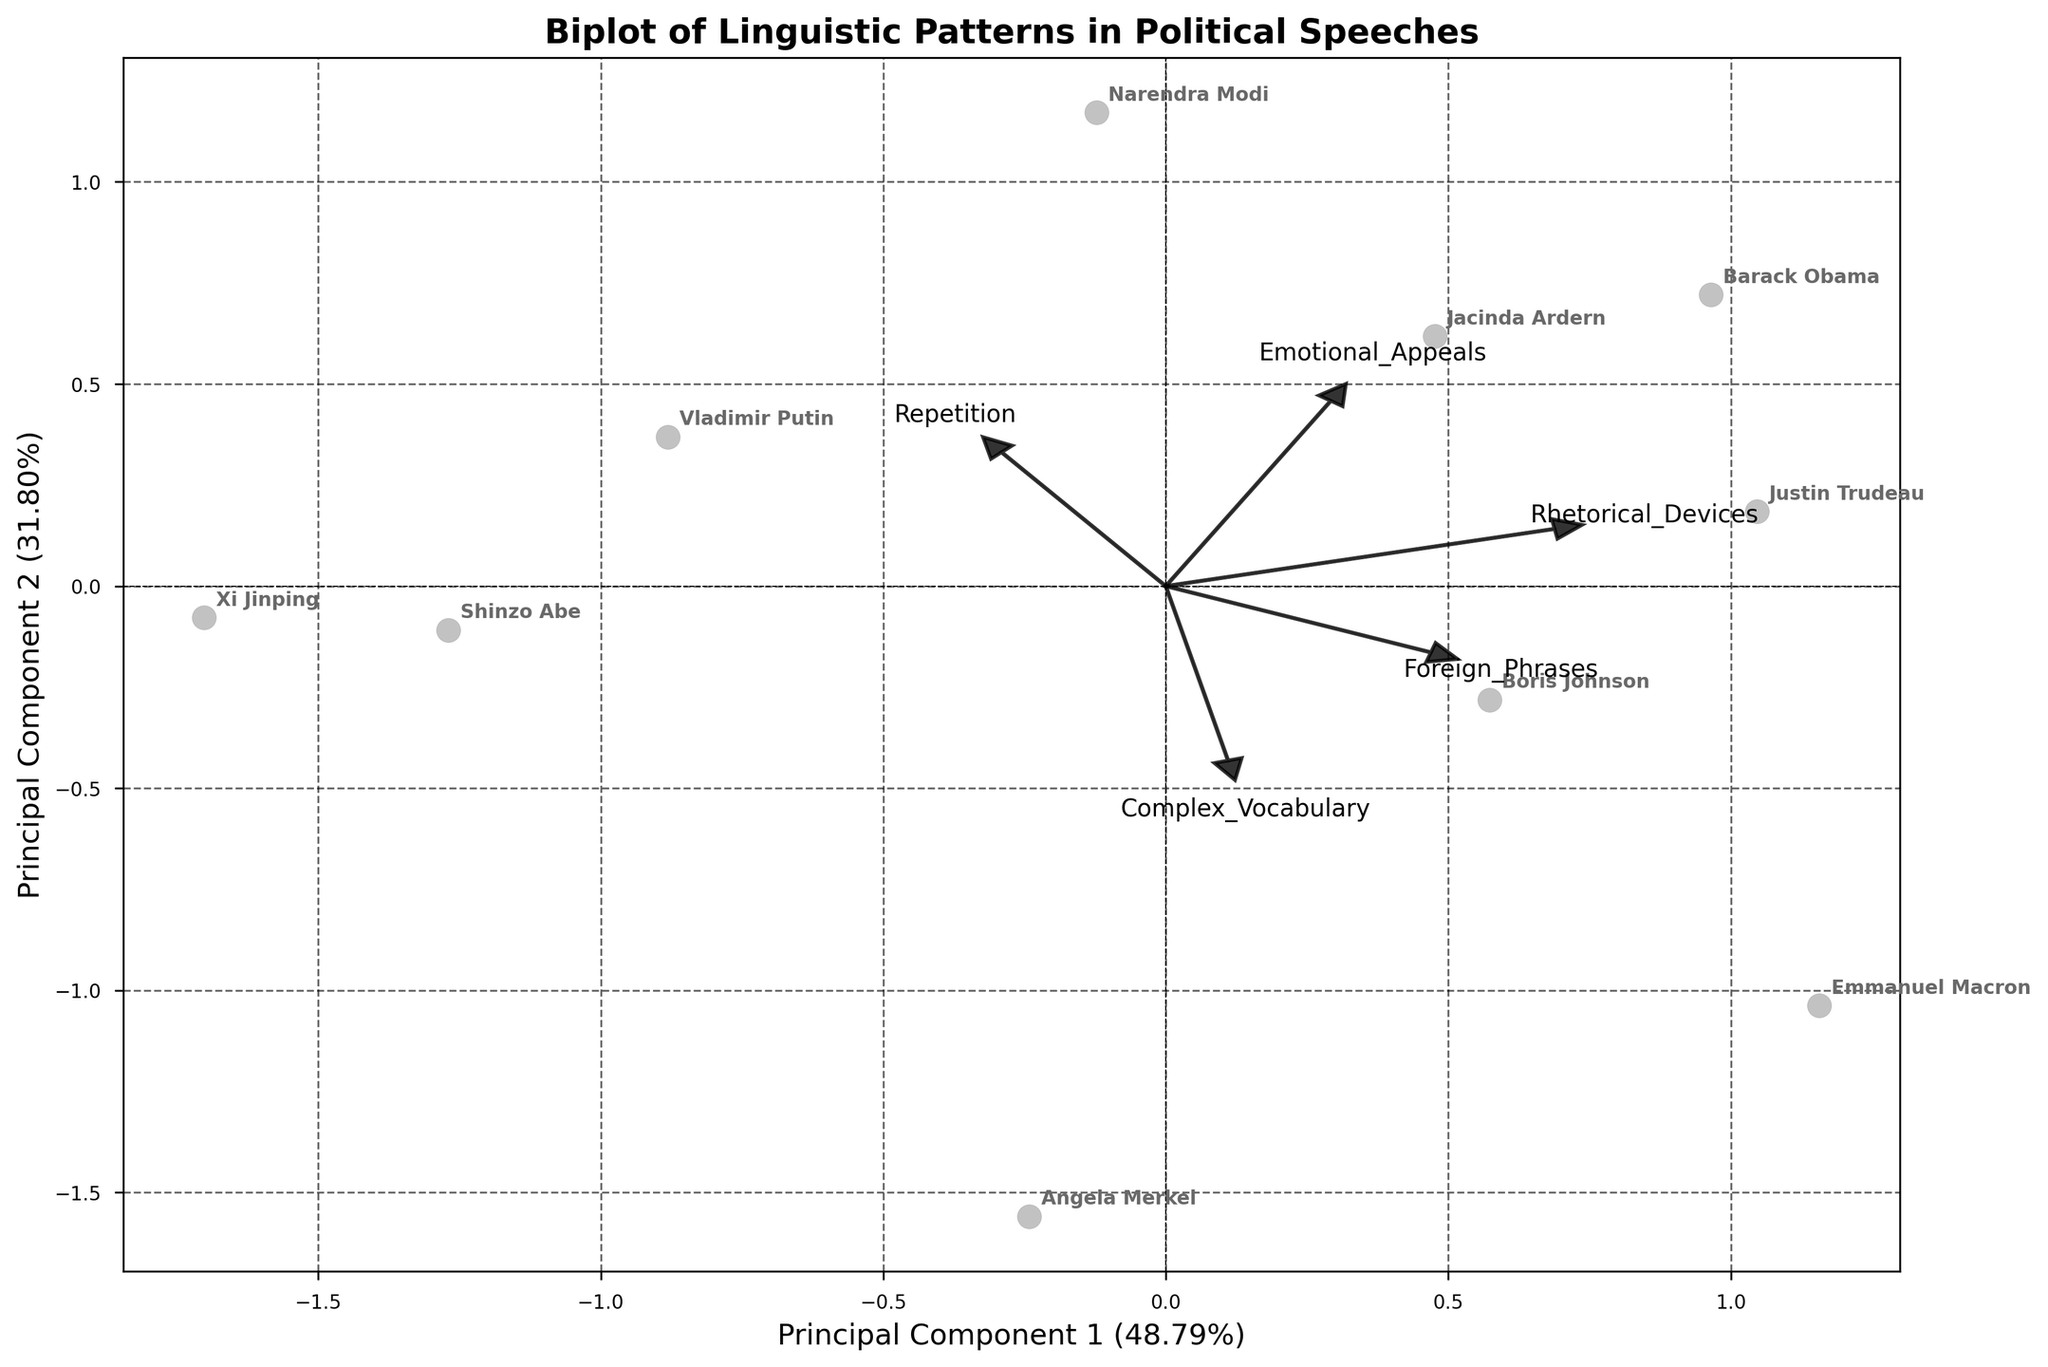How many leaders are represented in the biplot? Count the number of labels present in the plot. There are 10 leaders in the data, so there should be 10 labels.
Answer: 10 What does Principal Component 1 represent in terms of explained variance? Look at the label of the x-axis, which shows the variance explanation percentage. It shows Principal Component 1 accounts for a certain percentage of variance.
Answer: Check the plot for exact value (should be a percentage) Which leader has the highest score on Principal Component 1? Identify the data point that is furthest along the x-axis (Principal Component 1). Compare the labels associated with these points.
Answer: Find the name corresponding to the point furthest right Which rhetorical device has the strongest loading on Principal Component 2? Look at the arrows representing the loadings on the y-axis (Principal Component 2). Identify which arrow associated with a rhetorical device stretches the furthest along the y-axis.
Answer: Identify and provide the device name How do Angela Merkel and Emmanuel Macron compare in terms of their linguistic patterns? Find the positions of Angela Merkel and Emmanuel Macron in the biplot. Observe the relative distances and directions from the origin. Compare their coordinates and note which rhetorical devices contribute to their positions.
Answer: Compare coordinates and arrow directions How do the rhetorical devices of Repetition and Emotional Appeals differ in their contributions to the Principal Components? Examine the arrows for Repetition and Emotional Appeals. Note their lengths and directions, which indicate the strength and angle of their contributions to the Principal Components.
Answer: Compare arrow lengths and directions Which leader makes the most use of foreign phrases? To identify this, locate the arrow representing foreign phrases and check which leader's data point aligns most closely with the end of this arrow.
Answer: Name the corresponding leader Are there leaders whose rhetorical patterns are similar based on the biplot? If so, who are they? Look for clusters or closely positioned data points in the biplot. Compare their distances from various loadings/arrows.
Answer: Identify names that are close together Which principal component is more strongly influenced by Complex Vocabulary? Look at the loading arrow for Complex Vocabulary and check whether it aligns more with the x-axis (Principal Component 1) or the y-axis (Principal Component 2).
Answer: Indicate Principal Component 1 or Principal Component 2 What percentage of the total variance is explained by the first two principal components together? Add the variance explained percentages shown on the x-axis and y-axis labels.
Answer: Sum the two percentages for the total variance 